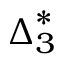<formula> <loc_0><loc_0><loc_500><loc_500>{ \Delta } _ { 3 } ^ { * }</formula> 